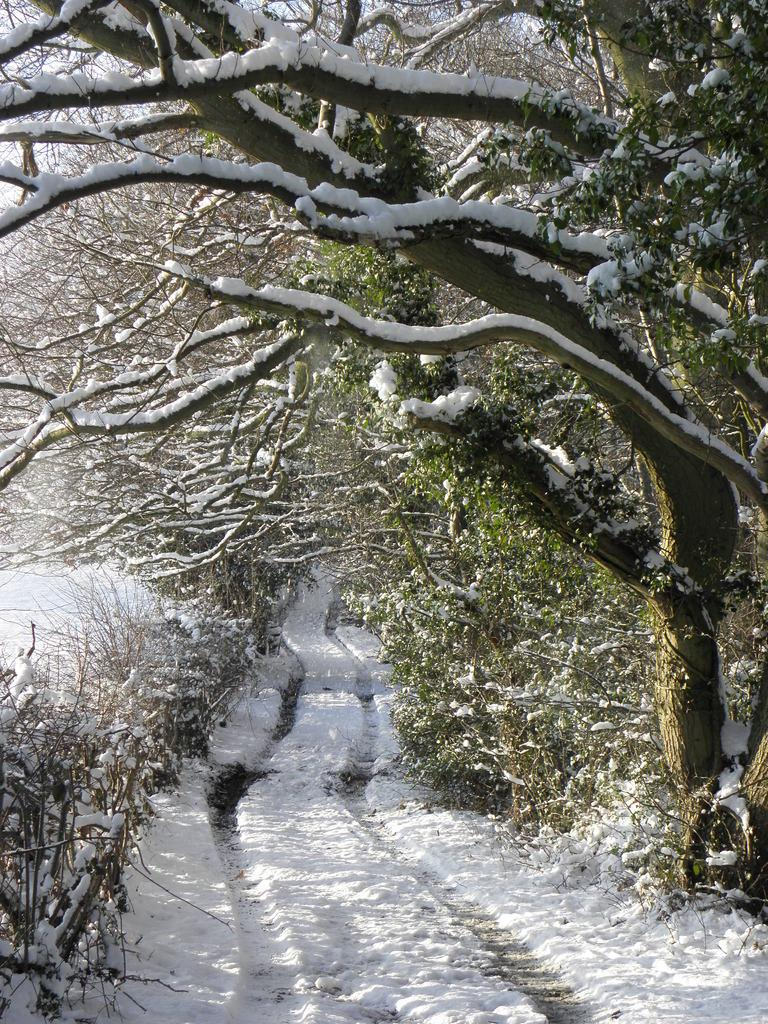What type of vegetation is present in the image? There are trees in the image. What is the condition of the trees in the image? The trees are covered with snow. What type of terrain is visible in the image? There is a land area in the image. What is the condition of the land area in the image? The land area is covered with snow. Where is the horn located in the image? There is no horn present in the image. Can you describe the stretch of land visible in the image? There is no specific stretch of land mentioned in the image; it simply shows a land area covered with snow. 